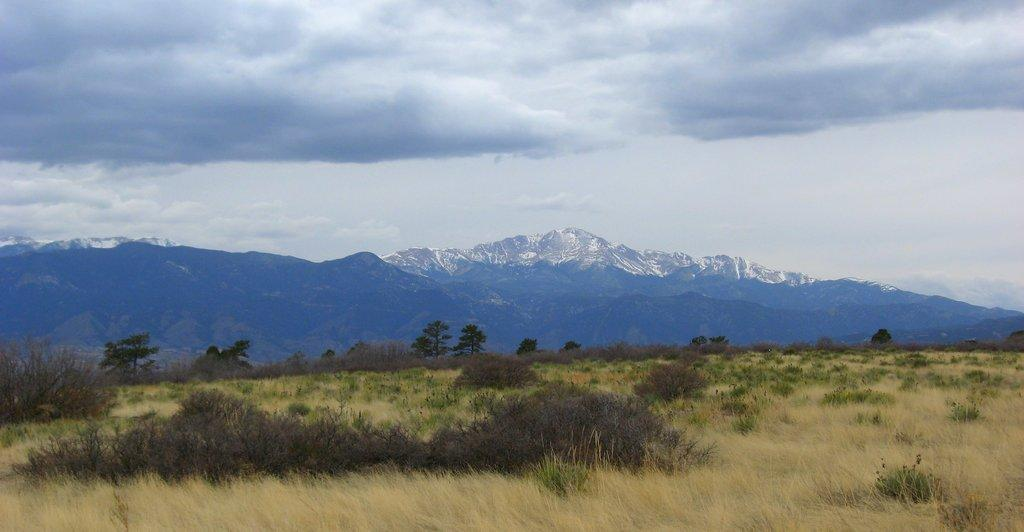What type of vegetation is present on the ground in the image? There is grass and plants on the ground in the image. What can be seen in the distance in the image? There are mountains in the background of the image. What part of the natural environment is visible in the image? The sky is visible in the image. What is present in the sky in the image? There are clouds in the sky. What type of hair can be seen on the lettuce in the image? There is no lettuce present in the image, and therefore no hair on it. Who needs to give approval for the mountains in the image? The image is a representation and does not require approval from anyone. 